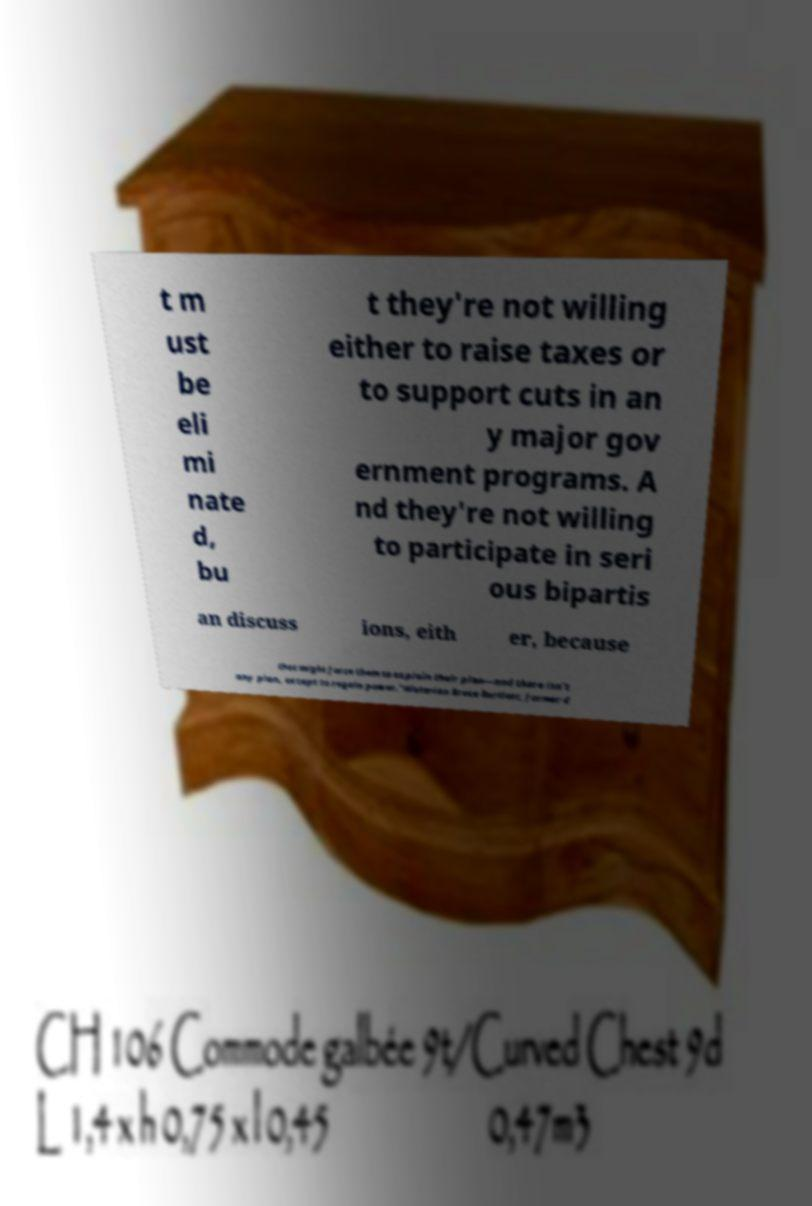For documentation purposes, I need the text within this image transcribed. Could you provide that? t m ust be eli mi nate d, bu t they're not willing either to raise taxes or to support cuts in an y major gov ernment programs. A nd they're not willing to participate in seri ous bipartis an discuss ions, eith er, because that might force them to explain their plan—and there isn't any plan, except to regain power."Historian Bruce Bartlett, former d 